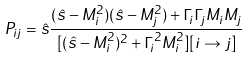<formula> <loc_0><loc_0><loc_500><loc_500>P _ { i j } = \hat { s } \frac { ( \hat { s } - M _ { i } ^ { 2 } ) ( \hat { s } - M _ { j } ^ { 2 } ) + \Gamma _ { i } \Gamma _ { j } M _ { i } M _ { j } } { [ ( \hat { s } - M _ { i } ^ { 2 } ) ^ { 2 } + \Gamma _ { i } ^ { 2 } M _ { i } ^ { 2 } ] [ i \rightarrow j ] }</formula> 